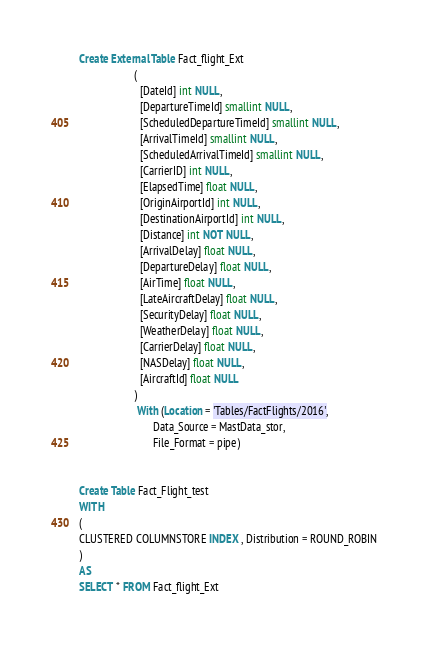<code> <loc_0><loc_0><loc_500><loc_500><_SQL_>Create External Table Fact_flight_Ext
					(
					  [DateId] int NULL, 
					  [DepartureTimeId] smallint NULL, 
					  [ScheduledDepartureTimeId] smallint NULL, 
					  [ArrivalTimeId] smallint NULL, 
				      [ScheduledArrivalTimeId] smallint NULL, 
					  [CarrierID] int NULL, 
					  [ElapsedTime] float NULL, 
					  [OriginAirportId] int NULL, 
					  [DestinationAirportId] int NULL, 
					  [Distance] int NOT NULL, 
				      [ArrivalDelay] float NULL, 
					  [DepartureDelay] float NULL, 
					  [AirTime] float NULL, 
					  [LateAircraftDelay] float NULL, 
					  [SecurityDelay] float NULL, 
					  [WeatherDelay] float NULL, 
					  [CarrierDelay] float NULL, 
					  [NASDelay] float NULL, 
					  [AircraftId] float NULL
					)
					 With (Location = 'Tables/FactFlights/2016', 
						   Data_Source = MastData_stor,
						   File_Format = pipe)


Create Table Fact_Flight_test
WITH
(
CLUSTERED COLUMNSTORE INDEX , Distribution = ROUND_ROBIN 
)
AS 
SELECT * FROM Fact_flight_Ext</code> 